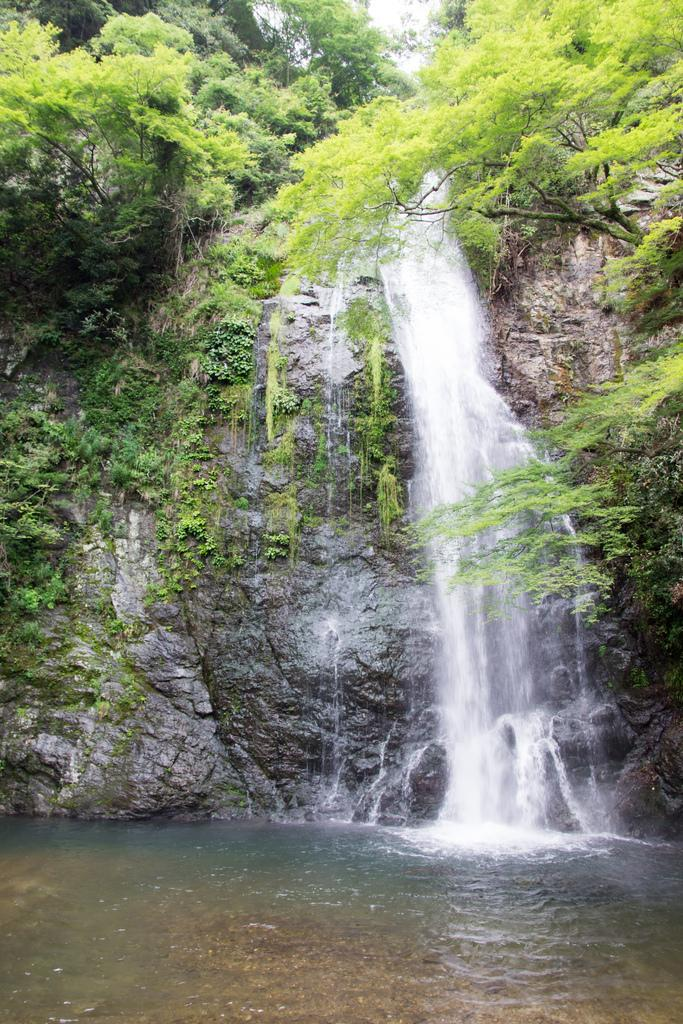What type of vegetation is visible in the image? There are trees in the image. What is the ground covered with in the image? There is grass in the image. What natural feature can be seen in the image? There is a waterfall in the image. Where is the house located in the image? There is no house present in the image. How many planes can be seen flying in the image? There are no planes visible in the image. 